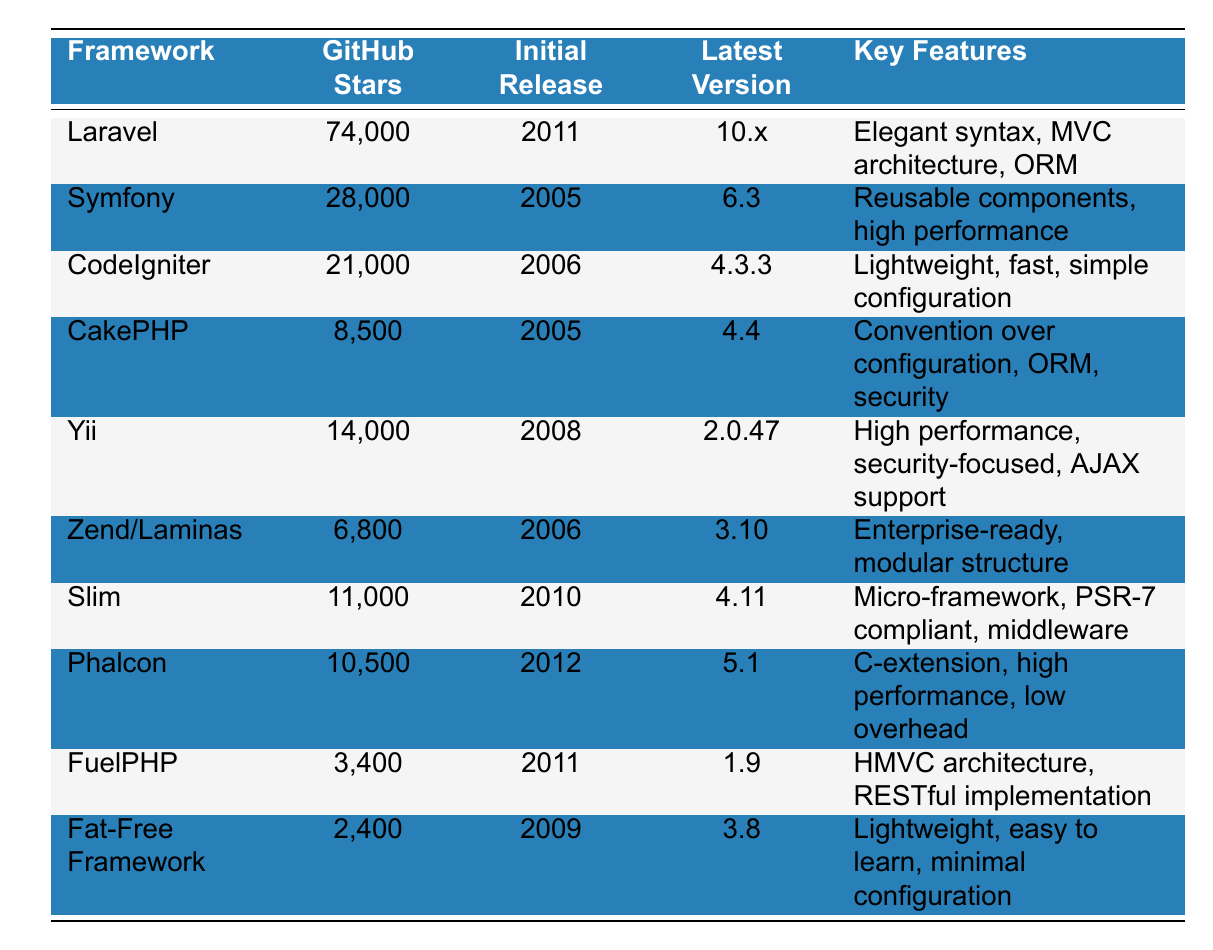What PHP framework has the most GitHub stars? By inspecting the "GitHub Stars" column, we can identify that Laravel has the highest number of stars at 74,000.
Answer: Laravel Which PHP framework was released first? Looking at the "Initial Release" column, Symfony was released in 2005, which is earlier than any other framework listed.
Answer: Symfony What is the latest version of CakePHP? The "Latest Version" column shows that the most recent version of CakePHP is 4.4.
Answer: 4.4 How many GitHub stars do Zend/Laminas have? The value in the "GitHub Stars" column for Zend/Laminas is listed as 6,800.
Answer: 6,800 Which frameworks have more than 10,000 GitHub stars? By reviewing the "GitHub Stars" column, we find that the frameworks Laravel, Symfony, CodeIgniter, Yii, Slim, and Phalcon all have more than 10,000 stars.
Answer: Laravel, Symfony, CodeIgniter, Yii, Slim, Phalcon Which framework has the least number of GitHub stars, and how many does it have? The "GitHub Stars" column indicates that Fat-Free Framework has the fewest stars, with a total of 2,400.
Answer: Fat-Free Framework, 2,400 What is the difference in GitHub stars between Laravel and CodeIgniter? Laravel has 74,000 stars while CodeIgniter has 21,000 stars, so the difference is 74,000 - 21,000 = 53,000.
Answer: 53,000 Is the latest version of Yii greater than its initial release year? Yii's initial release was in 2008, and the latest version is 2.0.47. Since this versioning is related to its updates and does not change the year of the initial release, the answer is no.
Answer: No What percentage of GitHub stars does CakePHP have compared to Laravel? CakePHP has 8,500 stars, while Laravel has 74,000 stars. The percentage is (8,500/74,000) * 100 = ~11.49%.
Answer: ~11.49% Which frameworks were released in the same year? By scanning the "Initial Release" column, CodeIgniter and Zend/Laminas were both released in 2006.
Answer: CodeIgniter, Zend/Laminas 